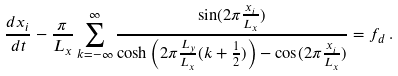<formula> <loc_0><loc_0><loc_500><loc_500>\frac { d x _ { i } } { d t } - \frac { \pi } { L _ { x } } \sum _ { k = - \infty } ^ { \infty } \frac { \sin ( 2 \pi \frac { x _ { i } } { L _ { x } } ) } { \cosh \left ( 2 \pi \frac { L _ { y } } { L _ { x } } ( k + \frac { 1 } { 2 } ) \right ) - \cos ( 2 \pi \frac { x _ { i } } { L _ { x } } ) } = f _ { d } \, .</formula> 